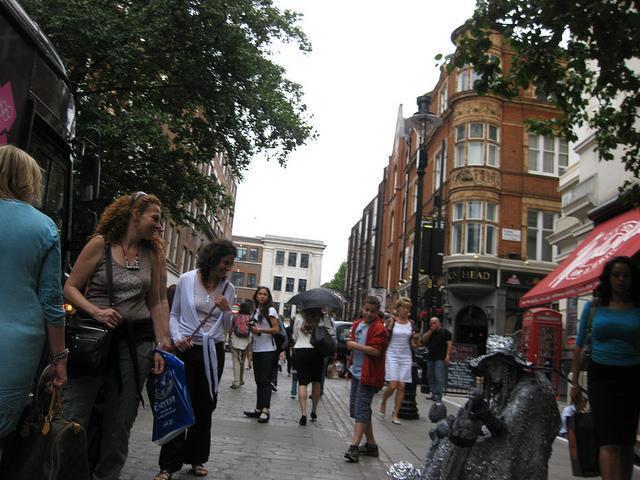How many people using an umbrella?
Give a very brief answer. 1. How many handbags are there?
Give a very brief answer. 3. How many people are visible?
Give a very brief answer. 9. 